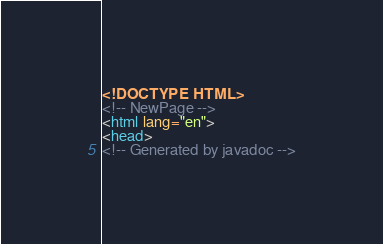Convert code to text. <code><loc_0><loc_0><loc_500><loc_500><_HTML_><!DOCTYPE HTML>
<!-- NewPage -->
<html lang="en">
<head>
<!-- Generated by javadoc --></code> 